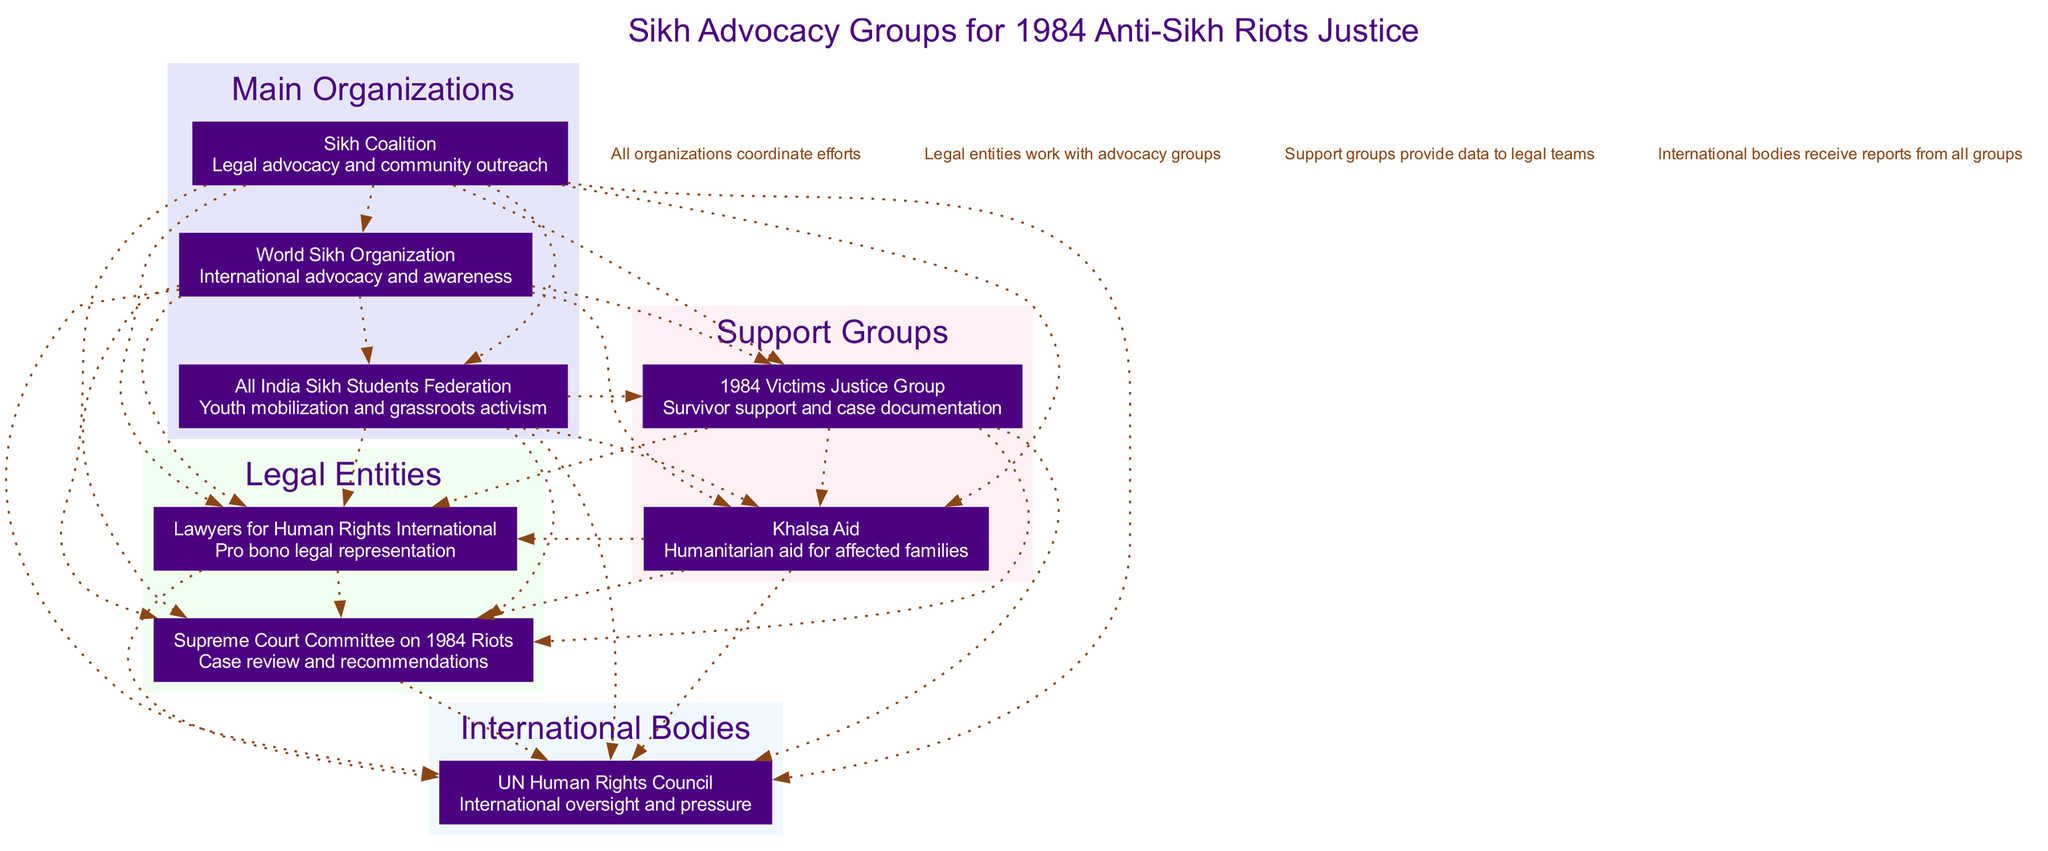What are the main organizations listed in the diagram? The diagram contains three main organizations: Sikh Coalition, World Sikh Organization, and All India Sikh Students Federation. These are explicitly stated in the section dedicated to main organizations.
Answer: Sikh Coalition, World Sikh Organization, All India Sikh Students Federation How many support groups are there? The diagram lists two support groups: 1984 Victims Justice Group and Khalsa Aid, which can be found in the support groups section. Counting these gives us the total number of support groups.
Answer: 2 What role does the Sikh Coalition play? In the diagram, the Sikh Coalition is described with the role of "Legal advocacy and community outreach," which is specified directly beneath the organization's name in the main organizations section.
Answer: Legal advocacy and community outreach Which international body is included in the diagram? The diagram features one international body, which is the UN Human Rights Council, listed in the international bodies section. This is the only organization mentioned under that category.
Answer: UN Human Rights Council How many connections are there between nodes? The diagram indicates that all organizations coordinate efforts, and since each of the main organizations, support groups, legal entities, and international bodies is connected to each other, the total count of connections can be calculated as combinations of the nodes involved. There are 7 organizations in total, leading to a large number of connections, but it specifically references the connections stated in the connections section.
Answer: Many (specific number may vary) Which group focuses on survivor support? According to the diagram, the 1984 Victims Justice Group is identified as focusing on survivor support and case documentation, explicitly mentioned in the section for support groups.
Answer: 1984 Victims Justice Group What role do legal entities have in the diagram? The legal entities are shown to provide pro bono legal representation and case review recommendations, which are their specific roles highlighted in the legal entities section of the diagram. This demonstrates their function in seeking justice for the victims.
Answer: Pro bono legal representation, case review recommendations How do support groups assist legal teams? The diagram states that support groups provide data to legal teams, indicating their collaborative role in supporting the legal advocacy process pertaining to justice for riot victims.
Answer: Provide data to legal teams What role does Khalsa Aid play? Khalsa Aid's role, as mentioned in the diagram, is to provide humanitarian aid for affected families, emphasizing its focus on relief efforts post-1984 anti-Sikh riots, which is stated clearly in the support groups section.
Answer: Humanitarian aid for affected families 